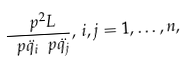<formula> <loc_0><loc_0><loc_500><loc_500>\frac { \ p ^ { 2 } L } { \ p \ddot { q _ { i } } \ p \ddot { q _ { j } } } , \, i , j = 1 , \dots , n ,</formula> 